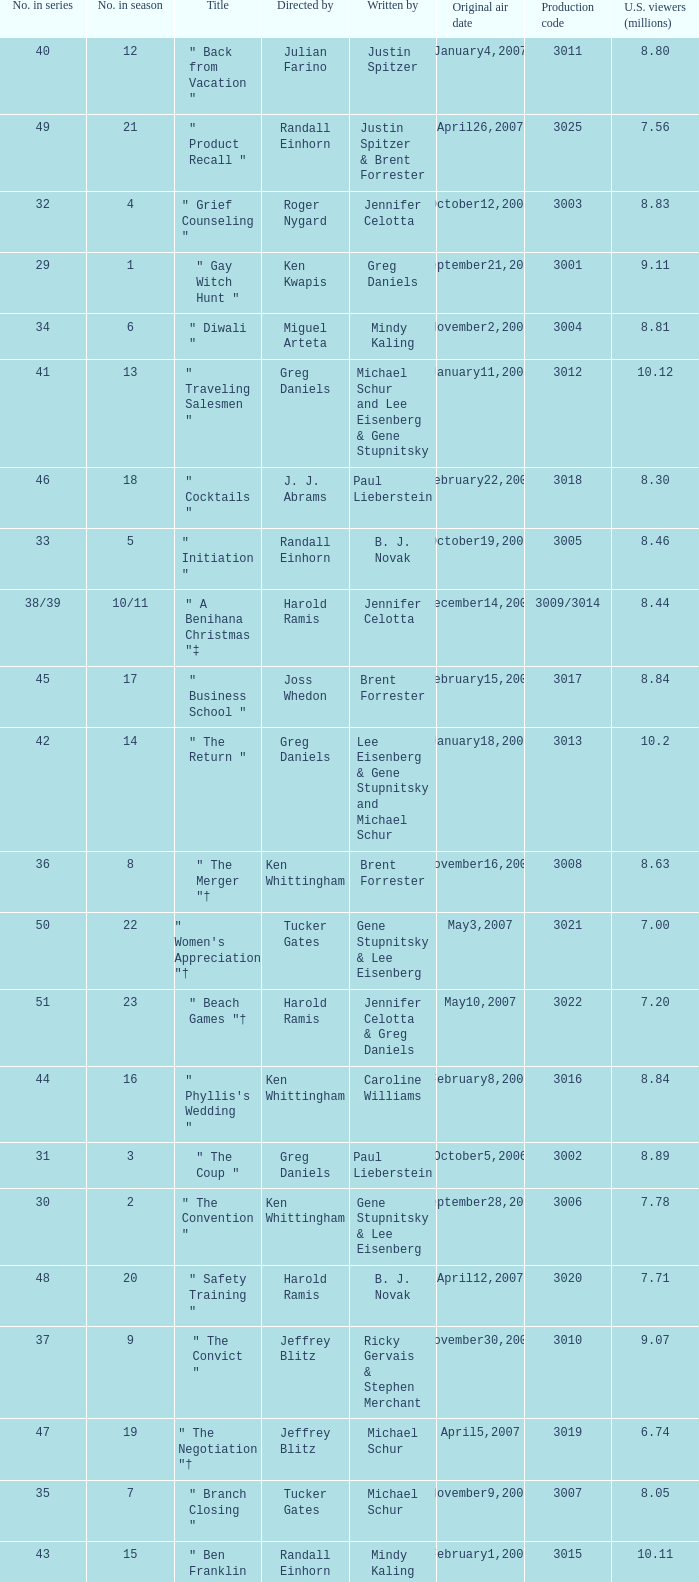Name the total number of titles for 3020 production code 1.0. 